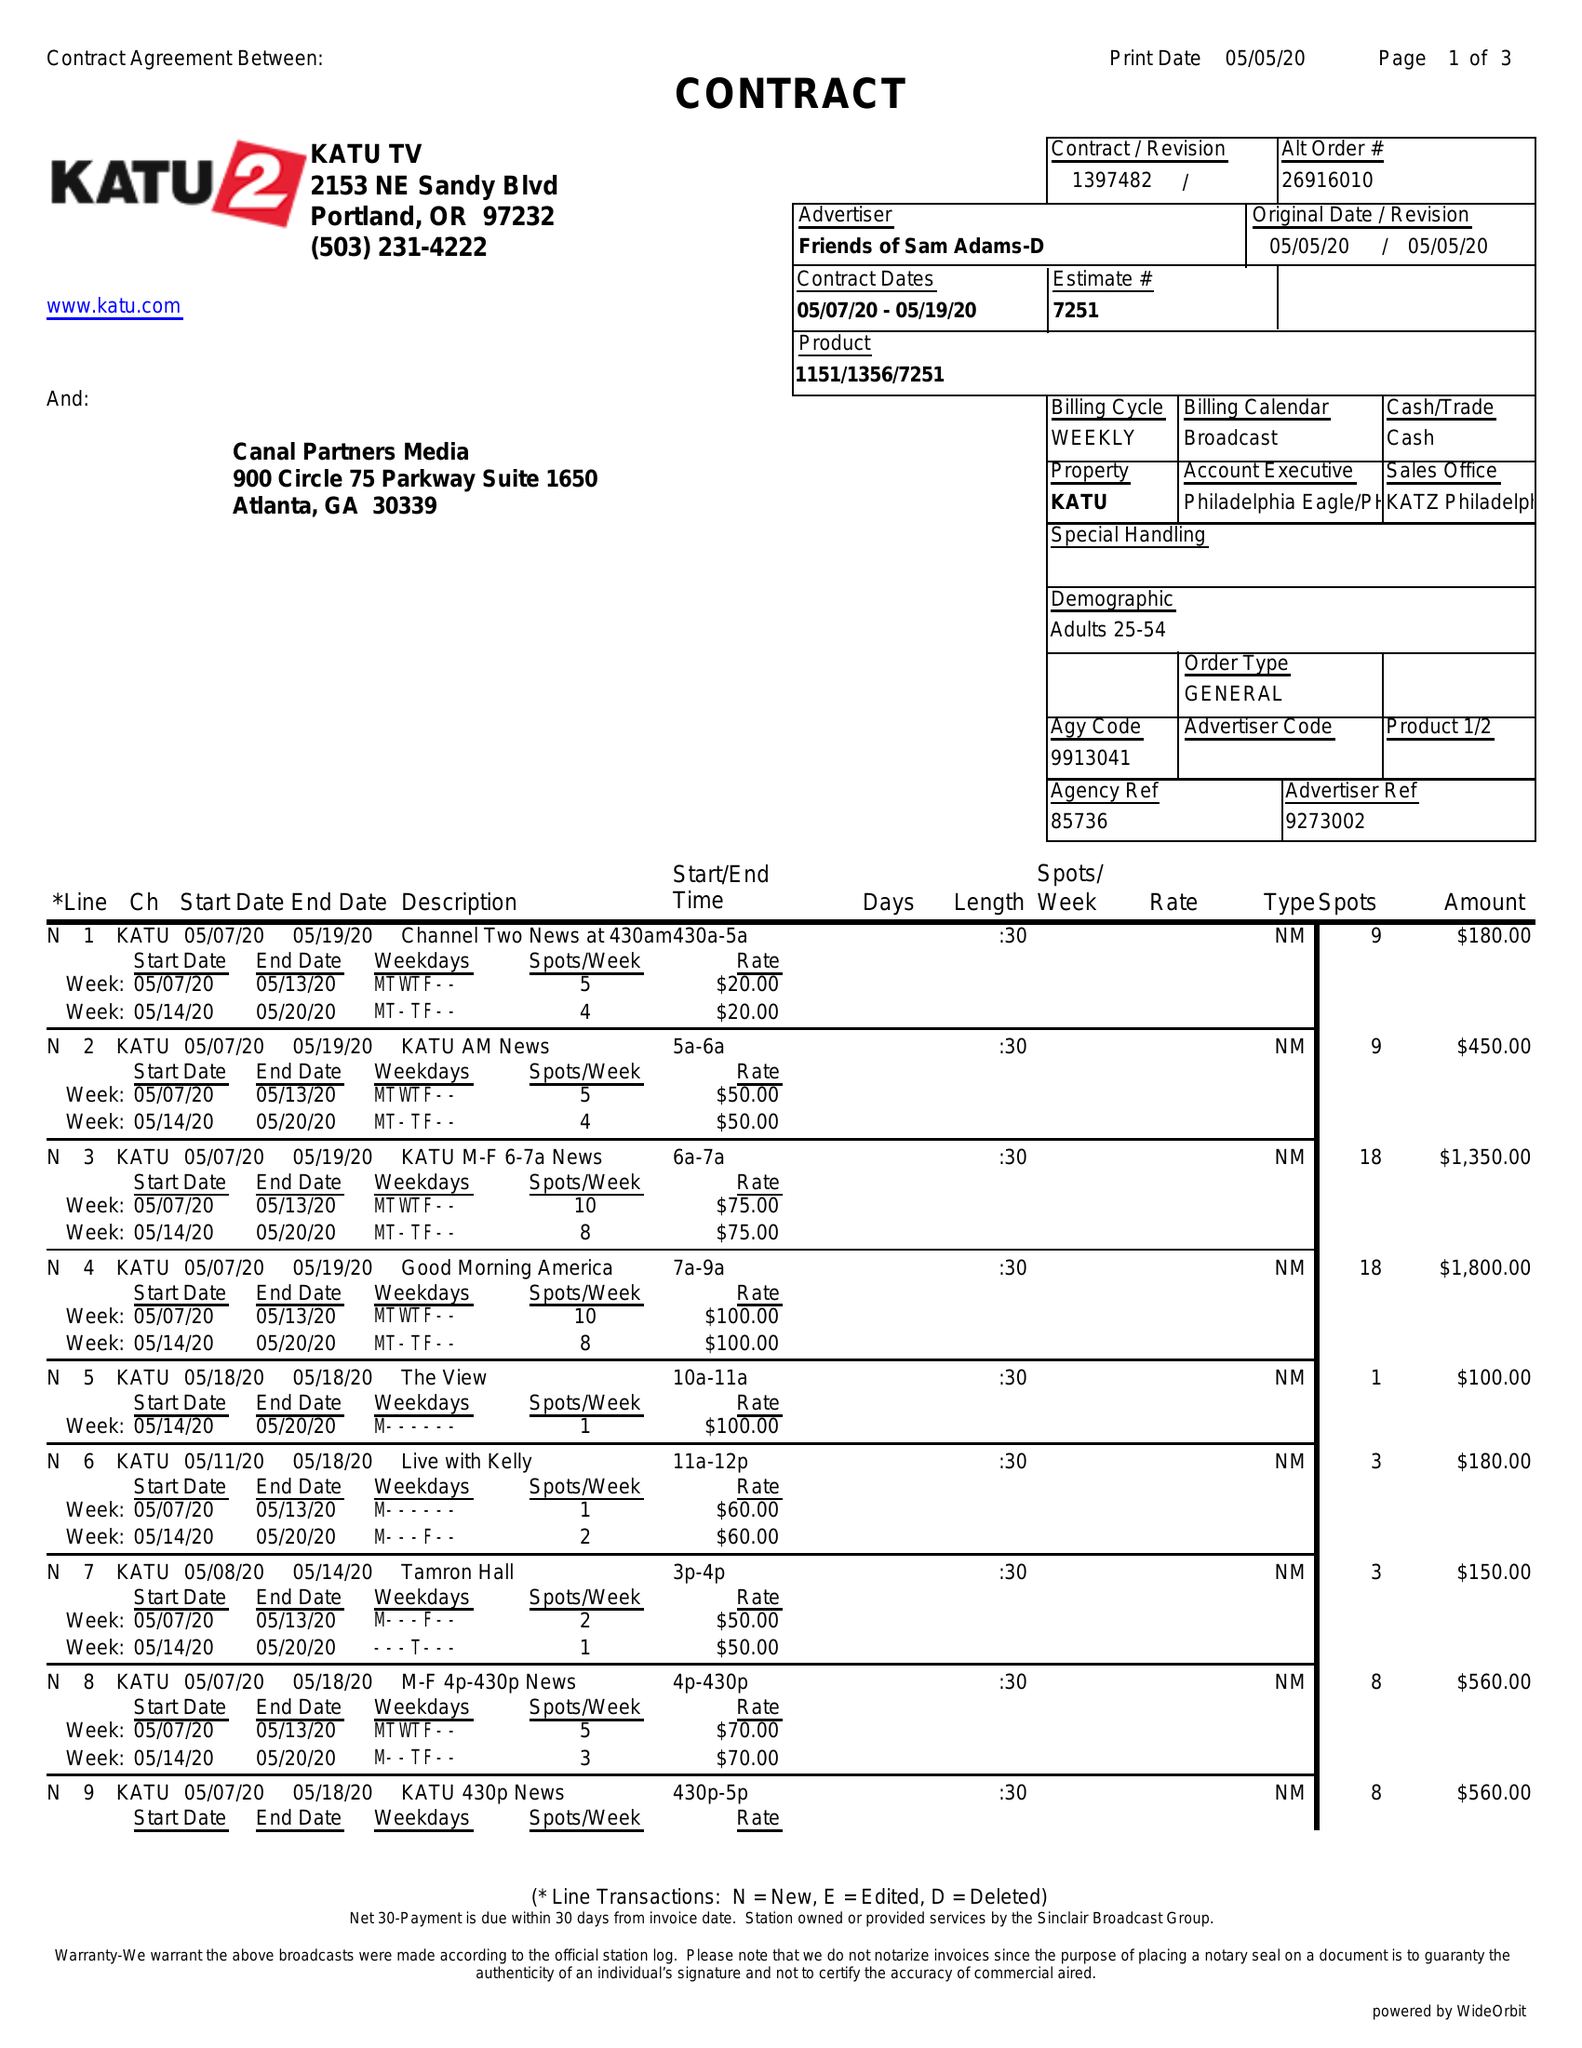What is the value for the flight_to?
Answer the question using a single word or phrase. 05/19/20 